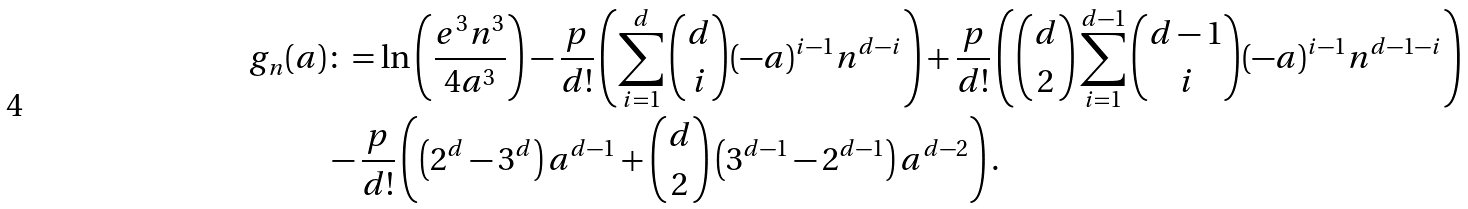<formula> <loc_0><loc_0><loc_500><loc_500>g _ { n } ( a ) & \colon = \ln \left ( \frac { e ^ { 3 } n ^ { 3 } } { 4 a ^ { 3 } } \right ) - \frac { p } { d ! } \left ( \sum _ { i = 1 } ^ { d } { d \choose i } ( - a ) ^ { i - 1 } n ^ { d - i } \right ) + \frac { p } { d ! } \left ( { d \choose 2 } \sum _ { i = 1 } ^ { d - 1 } { d - 1 \choose i } ( - a ) ^ { i - 1 } n ^ { d - 1 - i } \right ) \\ & - \frac { p } { d ! } \left ( \left ( 2 ^ { d } - 3 ^ { d } \right ) a ^ { d - 1 } + { d \choose 2 } \left ( 3 ^ { d - 1 } - 2 ^ { d - 1 } \right ) a ^ { d - 2 } \right ) .</formula> 